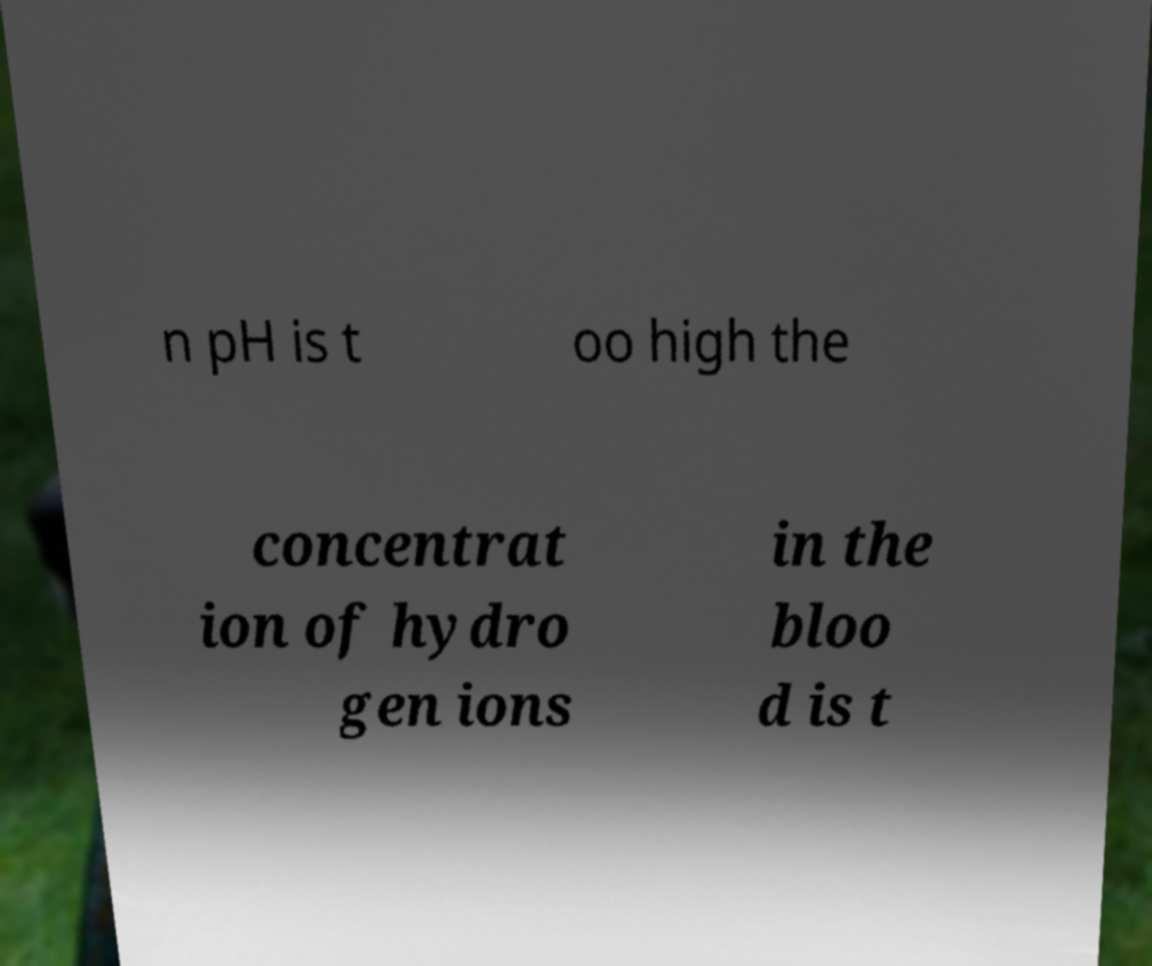Please read and relay the text visible in this image. What does it say? n pH is t oo high the concentrat ion of hydro gen ions in the bloo d is t 